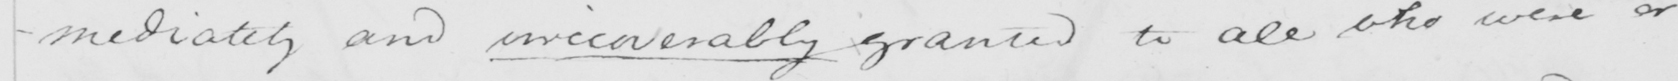Please provide the text content of this handwritten line. -mediately and irrecoverably granted to all who were or 